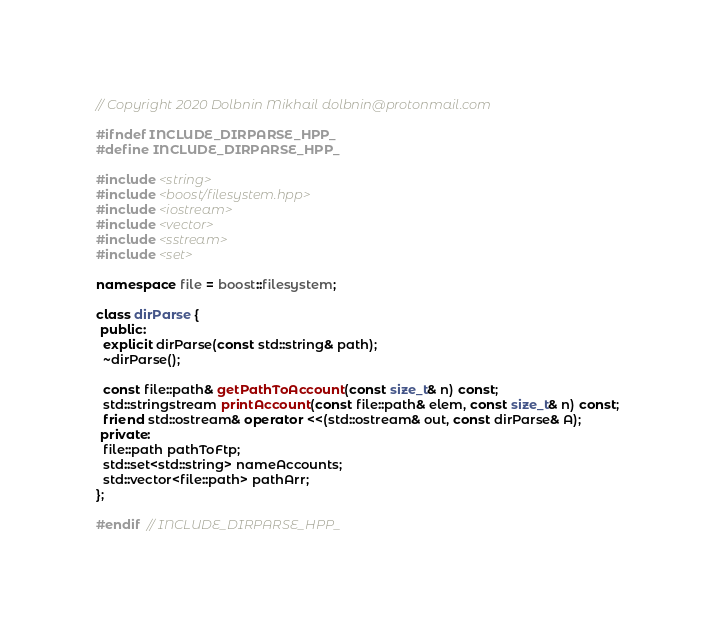<code> <loc_0><loc_0><loc_500><loc_500><_C++_>// Copyright 2020 Dolbnin Mikhail dolbnin@protonmail.com

#ifndef INCLUDE_DIRPARSE_HPP_
#define INCLUDE_DIRPARSE_HPP_

#include <string>
#include <boost/filesystem.hpp>
#include <iostream>
#include <vector>
#include <sstream>
#include <set>

namespace file = boost::filesystem;

class dirParse {
 public:
  explicit dirParse(const std::string& path);
  ~dirParse();

  const file::path& getPathToAccount(const size_t& n) const;
  std::stringstream printAccount(const file::path& elem, const size_t& n) const;
  friend std::ostream& operator <<(std::ostream& out, const dirParse& A);
 private:
  file::path pathToFtp;
  std::set<std::string> nameAccounts;
  std::vector<file::path> pathArr;
};

#endif  // INCLUDE_DIRPARSE_HPP_
</code> 